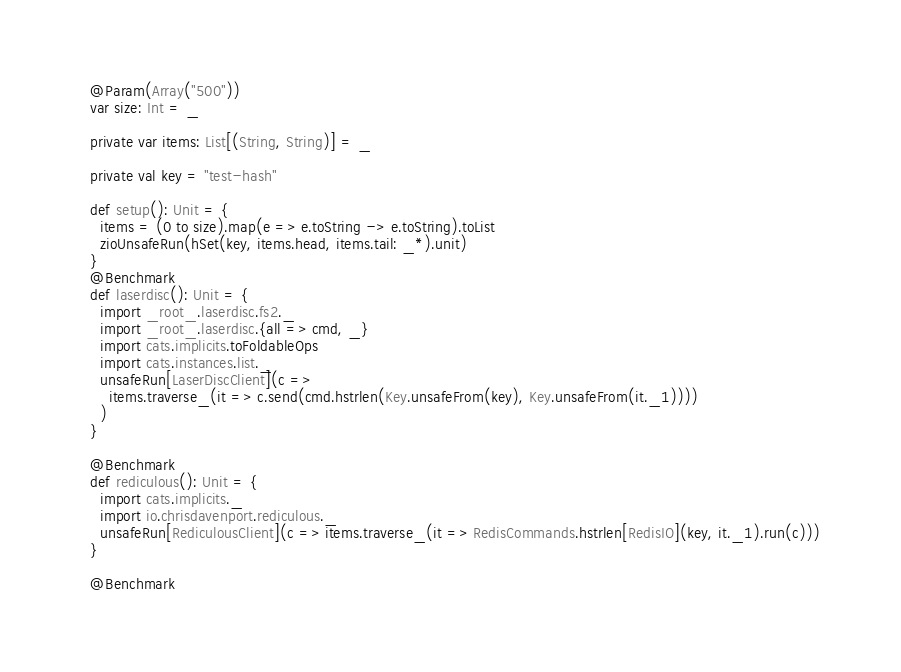<code> <loc_0><loc_0><loc_500><loc_500><_Scala_>  @Param(Array("500"))
  var size: Int = _

  private var items: List[(String, String)] = _

  private val key = "test-hash"

  def setup(): Unit = {
    items = (0 to size).map(e => e.toString -> e.toString).toList
    zioUnsafeRun(hSet(key, items.head, items.tail: _*).unit)
  }
  @Benchmark
  def laserdisc(): Unit = {
    import _root_.laserdisc.fs2._
    import _root_.laserdisc.{all => cmd, _}
    import cats.implicits.toFoldableOps
    import cats.instances.list._
    unsafeRun[LaserDiscClient](c =>
      items.traverse_(it => c.send(cmd.hstrlen(Key.unsafeFrom(key), Key.unsafeFrom(it._1))))
    )
  }

  @Benchmark
  def rediculous(): Unit = {
    import cats.implicits._
    import io.chrisdavenport.rediculous._
    unsafeRun[RediculousClient](c => items.traverse_(it => RedisCommands.hstrlen[RedisIO](key, it._1).run(c)))
  }

  @Benchmark</code> 